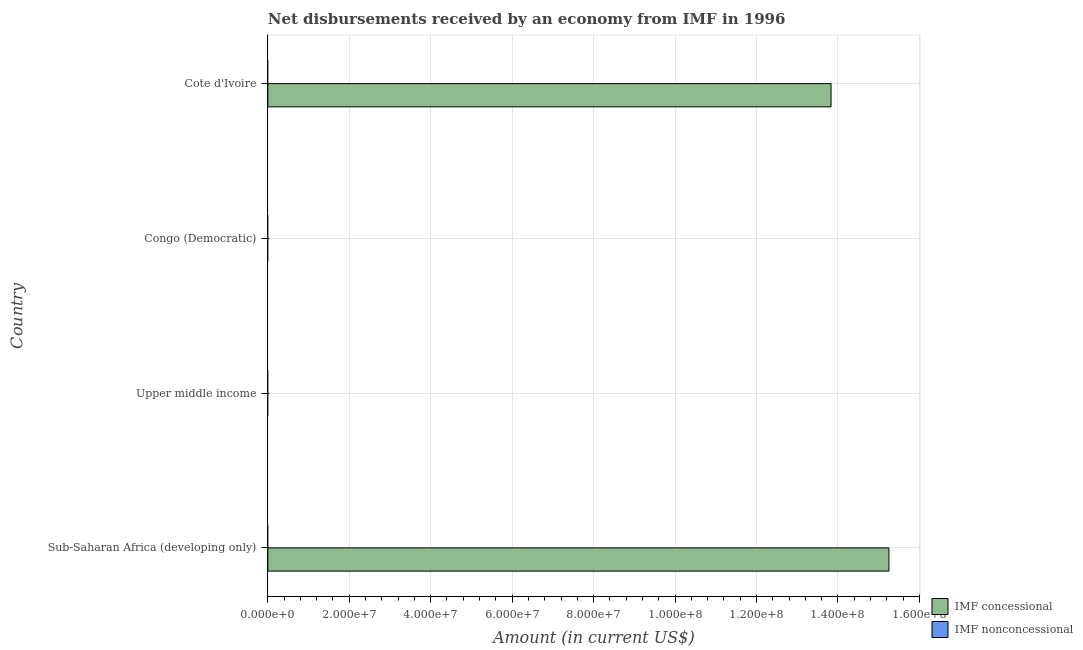How many different coloured bars are there?
Provide a short and direct response. 1. Are the number of bars per tick equal to the number of legend labels?
Provide a short and direct response. No. How many bars are there on the 3rd tick from the top?
Offer a very short reply. 0. How many bars are there on the 3rd tick from the bottom?
Offer a terse response. 0. What is the label of the 1st group of bars from the top?
Offer a very short reply. Cote d'Ivoire. Across all countries, what is the maximum net concessional disbursements from imf?
Keep it short and to the point. 1.53e+08. Across all countries, what is the minimum net non concessional disbursements from imf?
Keep it short and to the point. 0. In which country was the net concessional disbursements from imf maximum?
Offer a terse response. Sub-Saharan Africa (developing only). What is the total net concessional disbursements from imf in the graph?
Make the answer very short. 2.91e+08. What is the difference between the net non concessional disbursements from imf in Cote d'Ivoire and the net concessional disbursements from imf in Upper middle income?
Ensure brevity in your answer.  0. In how many countries, is the net concessional disbursements from imf greater than 20000000 US$?
Your answer should be compact. 2. What is the difference between the highest and the lowest net concessional disbursements from imf?
Offer a very short reply. 1.53e+08. In how many countries, is the net non concessional disbursements from imf greater than the average net non concessional disbursements from imf taken over all countries?
Your answer should be compact. 0. How many bars are there?
Ensure brevity in your answer.  2. What is the difference between two consecutive major ticks on the X-axis?
Ensure brevity in your answer.  2.00e+07. How are the legend labels stacked?
Keep it short and to the point. Vertical. What is the title of the graph?
Ensure brevity in your answer.  Net disbursements received by an economy from IMF in 1996. What is the label or title of the Y-axis?
Keep it short and to the point. Country. What is the Amount (in current US$) of IMF concessional in Sub-Saharan Africa (developing only)?
Keep it short and to the point. 1.53e+08. What is the Amount (in current US$) in IMF concessional in Upper middle income?
Offer a terse response. 0. What is the Amount (in current US$) of IMF nonconcessional in Congo (Democratic)?
Give a very brief answer. 0. What is the Amount (in current US$) in IMF concessional in Cote d'Ivoire?
Provide a succinct answer. 1.38e+08. Across all countries, what is the maximum Amount (in current US$) in IMF concessional?
Your answer should be compact. 1.53e+08. What is the total Amount (in current US$) of IMF concessional in the graph?
Provide a short and direct response. 2.91e+08. What is the total Amount (in current US$) of IMF nonconcessional in the graph?
Provide a succinct answer. 0. What is the difference between the Amount (in current US$) in IMF concessional in Sub-Saharan Africa (developing only) and that in Cote d'Ivoire?
Your answer should be very brief. 1.42e+07. What is the average Amount (in current US$) of IMF concessional per country?
Provide a succinct answer. 7.27e+07. What is the average Amount (in current US$) of IMF nonconcessional per country?
Provide a succinct answer. 0. What is the ratio of the Amount (in current US$) in IMF concessional in Sub-Saharan Africa (developing only) to that in Cote d'Ivoire?
Your answer should be compact. 1.1. What is the difference between the highest and the lowest Amount (in current US$) of IMF concessional?
Keep it short and to the point. 1.53e+08. 